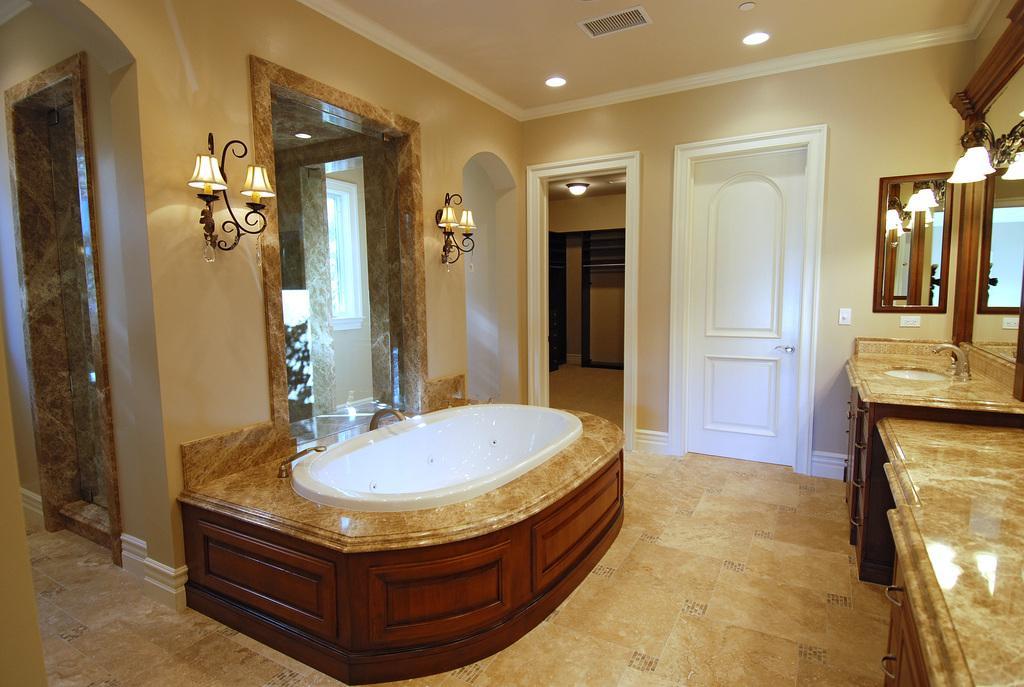How would you summarize this image in a sentence or two? In this image I can see bathtub,sink,tap and cupboard. The mirror and lights are attached to the wall. I can see white color door. The wall is in cream color. 